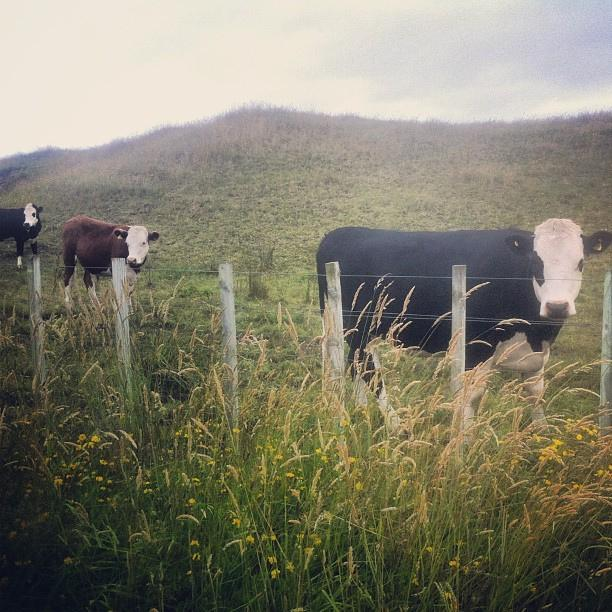What color is the cow in between the two milkcows?

Choices:
A) brown
B) ginger
C) green
D) pink brown 